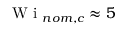<formula> <loc_0><loc_0><loc_500><loc_500>W i _ { n o m , c } \approx 5</formula> 